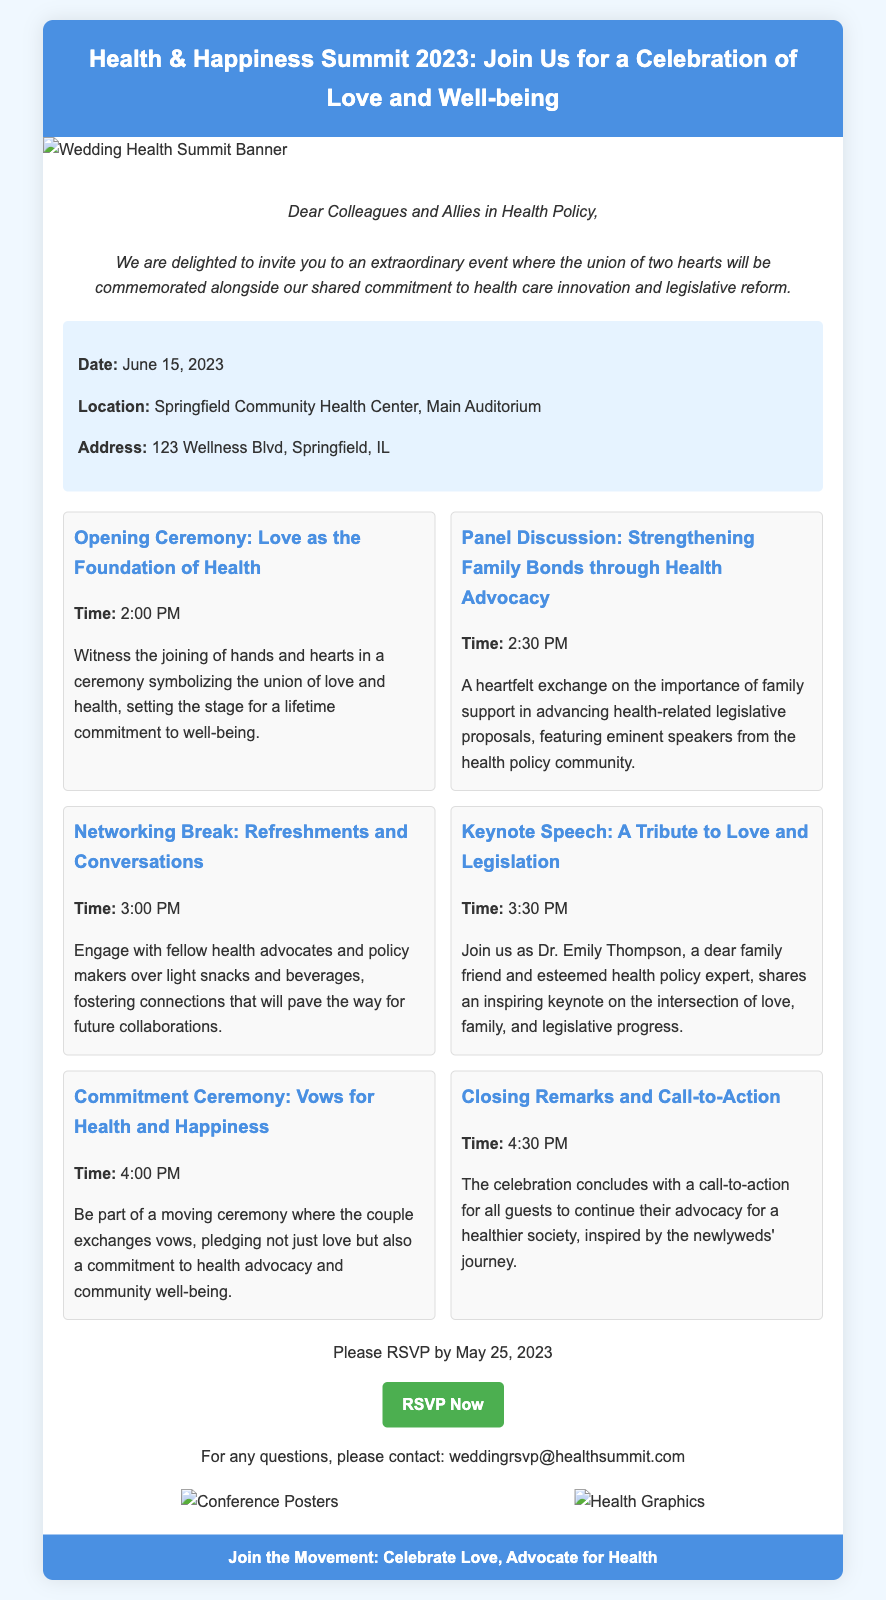What is the date of the event? The date is provided in the event details section of the invitation.
Answer: June 15, 2023 What is the main location for the summit? The location is mentioned in the event details section of the invitation.
Answer: Springfield Community Health Center, Main Auditorium Who is giving the keynote speech? The keynote speaker is listed in the session descriptions.
Answer: Dr. Emily Thompson What time does the commitment ceremony begin? The time is noted in the session for the commitment ceremony.
Answer: 4:00 PM What is the RSVP deadline? The RSVP deadline is provided in the RSVP section of the document.
Answer: May 25, 2023 